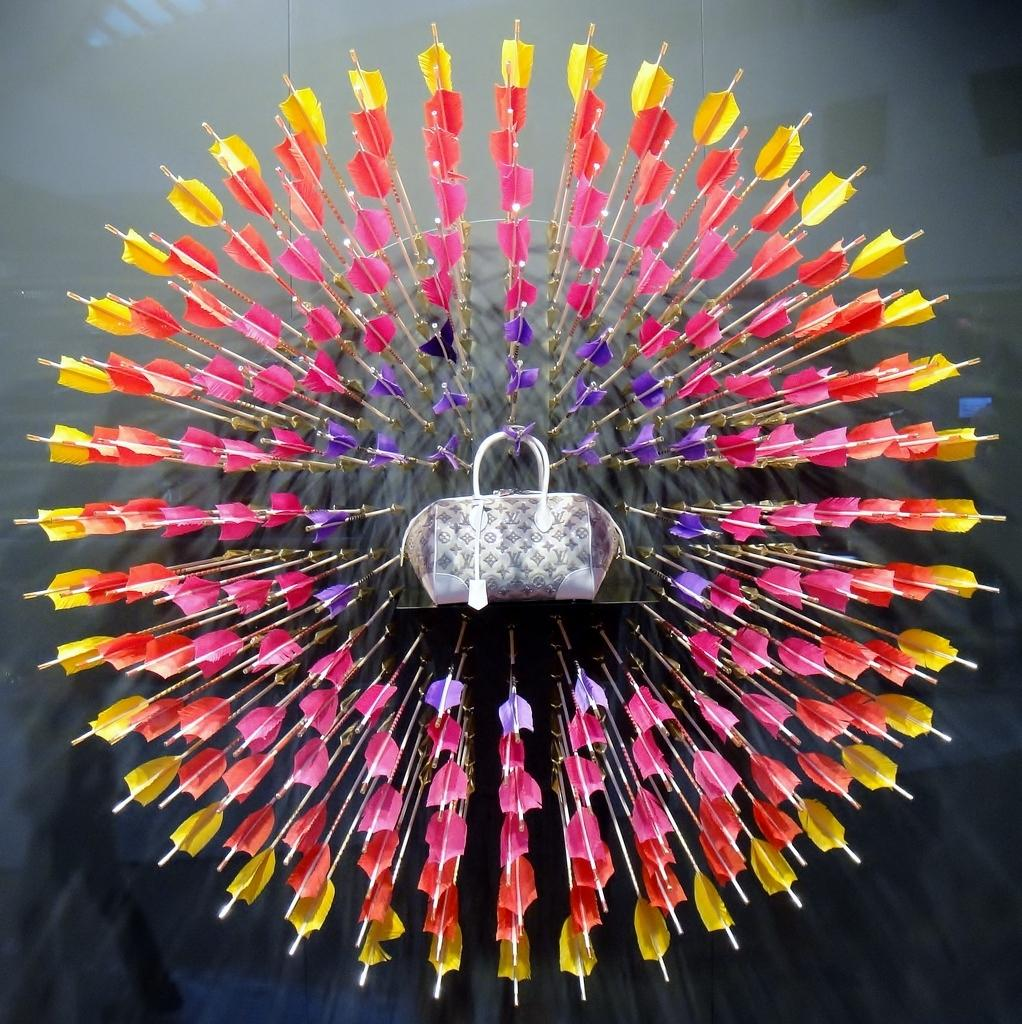What type of objects with a design are present in the image? There are arrows with a design in the image. What other item can be seen in the image? There is a handbag in the image. What is the color of the handbag? The handbag is white in color. Does the handbag have any additional features? Yes, the handbag has a tag. Can you see a wren perched on the handbag in the image? No, there is no wren present in the image. What type of bottle is being used to hold the arrows in the image? There is no bottle present in the image; the arrows have a design. 